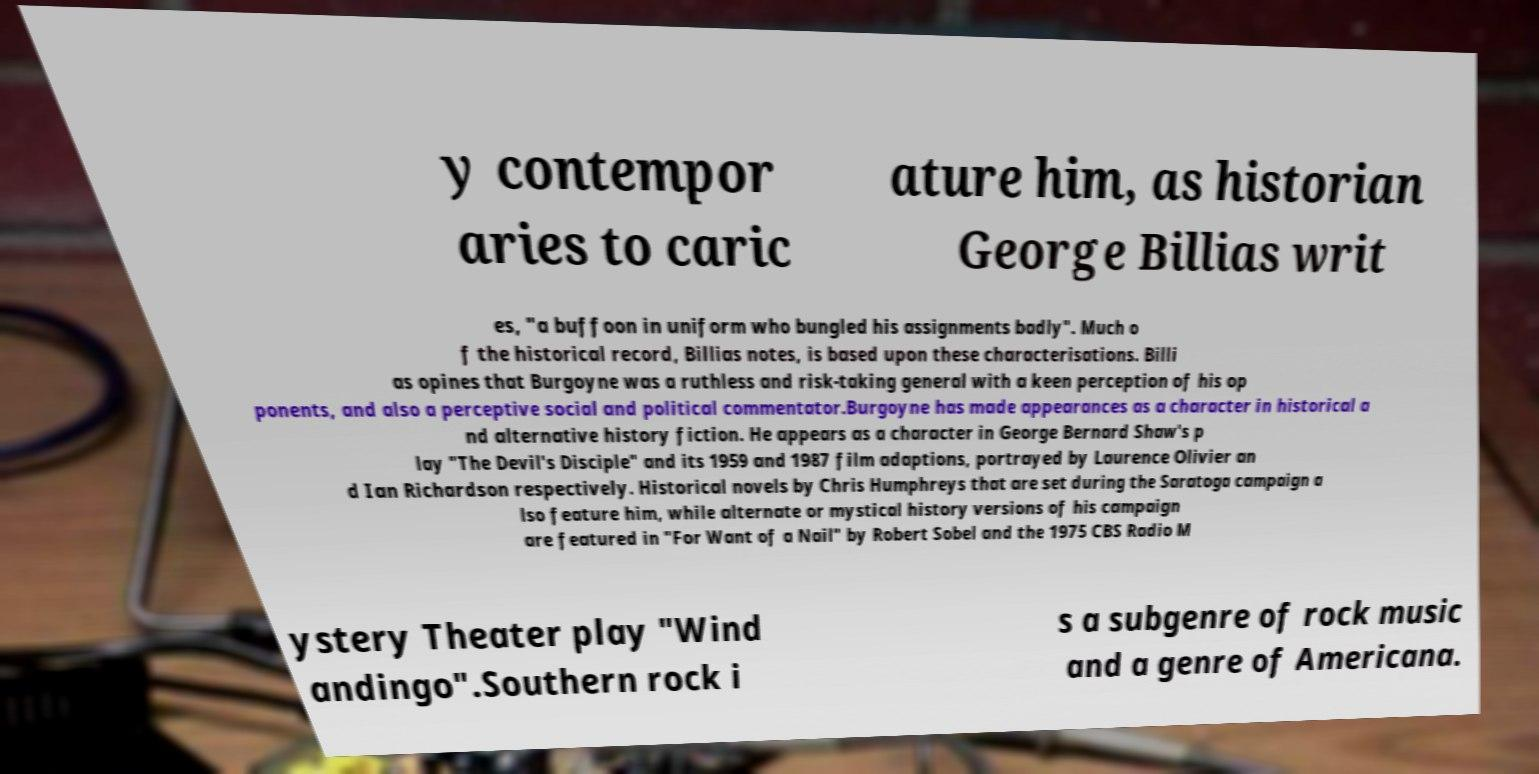Can you read and provide the text displayed in the image?This photo seems to have some interesting text. Can you extract and type it out for me? y contempor aries to caric ature him, as historian George Billias writ es, "a buffoon in uniform who bungled his assignments badly". Much o f the historical record, Billias notes, is based upon these characterisations. Billi as opines that Burgoyne was a ruthless and risk-taking general with a keen perception of his op ponents, and also a perceptive social and political commentator.Burgoyne has made appearances as a character in historical a nd alternative history fiction. He appears as a character in George Bernard Shaw's p lay "The Devil's Disciple" and its 1959 and 1987 film adaptions, portrayed by Laurence Olivier an d Ian Richardson respectively. Historical novels by Chris Humphreys that are set during the Saratoga campaign a lso feature him, while alternate or mystical history versions of his campaign are featured in "For Want of a Nail" by Robert Sobel and the 1975 CBS Radio M ystery Theater play "Wind andingo".Southern rock i s a subgenre of rock music and a genre of Americana. 